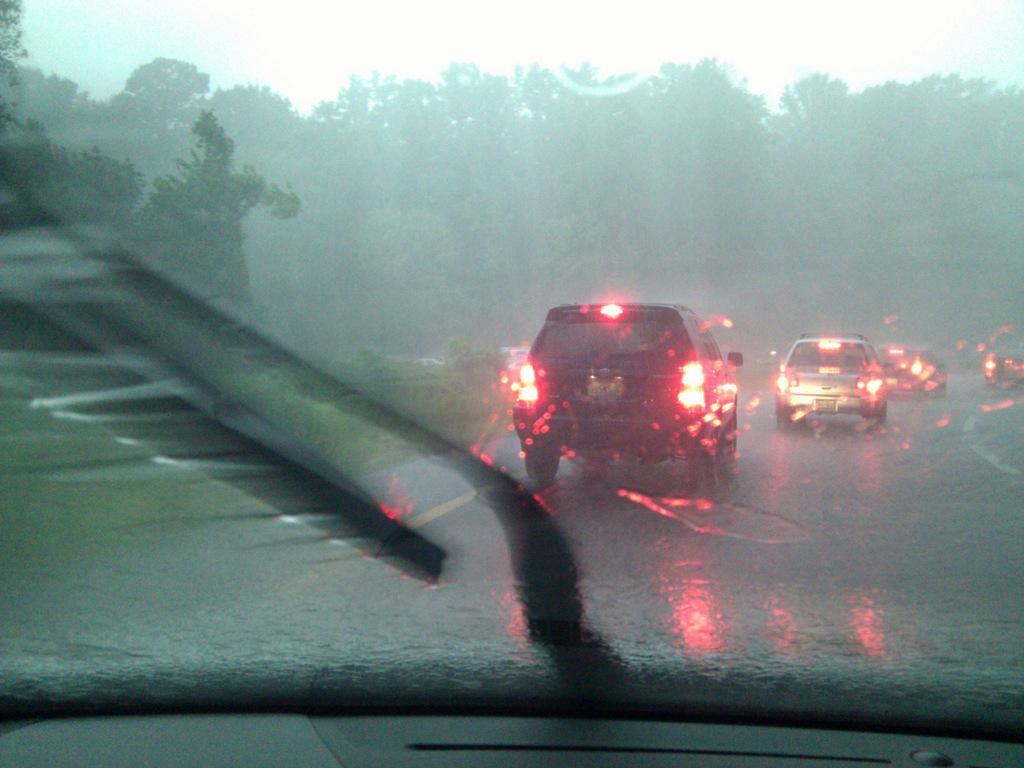Could you give a brief overview of what you see in this image? In this image I can see some vehicles on the road. In the background, I can see the trees. 